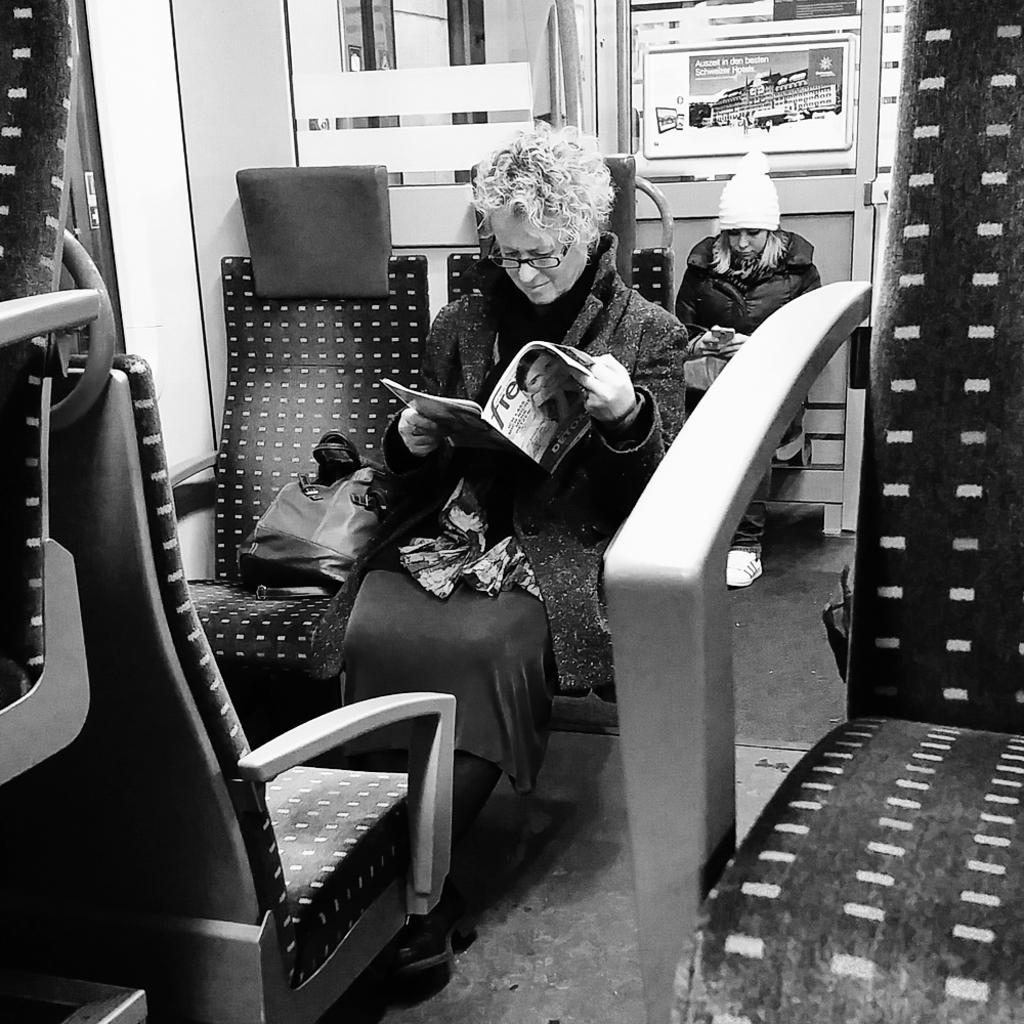Describe this image in one or two sentences. It is a black and white picture, the picture is taken inside the bus, there are two people a lady and a girl , sitting one followed by the other the first woman is reading a magazine that is a bag beside her ,the girl behind her is operating mobile in the background there is a door. 